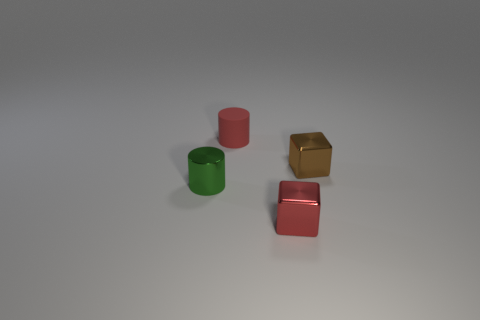Which objects seem to have a reflective surface? The golden cube and the two cylinders with a red hue appear to have reflective surfaces, as indicated by the light and shadows playing across their faces. 